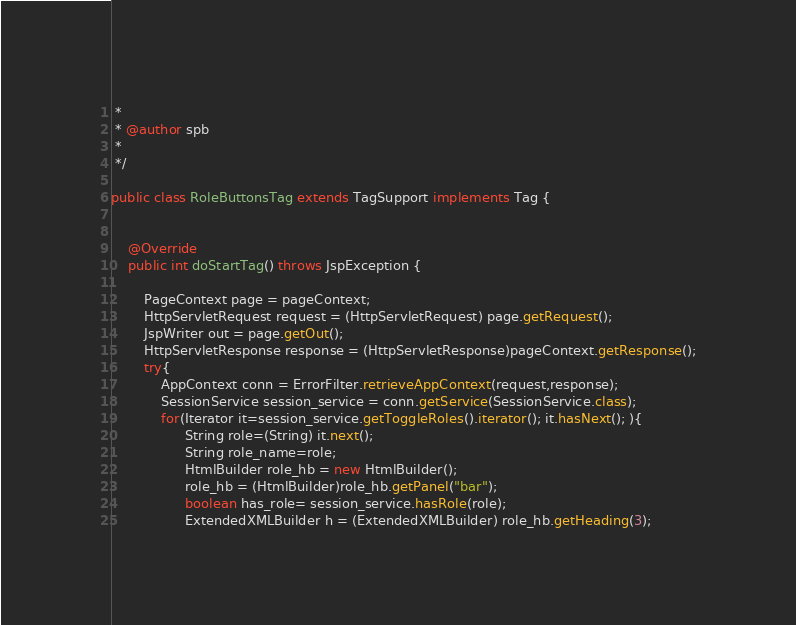Convert code to text. <code><loc_0><loc_0><loc_500><loc_500><_Java_> * 
 * @author spb
 *
 */

public class RoleButtonsTag extends TagSupport implements Tag {


	@Override
	public int doStartTag() throws JspException {
	
		PageContext page = pageContext;
		HttpServletRequest request = (HttpServletRequest) page.getRequest();
		JspWriter out = page.getOut();
        HttpServletResponse response = (HttpServletResponse)pageContext.getResponse();
        try{
        	AppContext conn = ErrorFilter.retrieveAppContext(request,response);
        	SessionService session_service = conn.getService(SessionService.class);
        	for(Iterator it=session_service.getToggleRoles().iterator(); it.hasNext(); ){
        		  String role=(String) it.next();
        		  String role_name=role;
        		  HtmlBuilder role_hb = new HtmlBuilder();
        		  role_hb = (HtmlBuilder)role_hb.getPanel("bar");
        		  boolean has_role= session_service.hasRole(role);
        		  ExtendedXMLBuilder h = (ExtendedXMLBuilder) role_hb.getHeading(3);</code> 